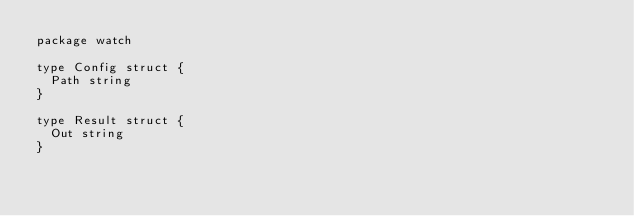<code> <loc_0><loc_0><loc_500><loc_500><_Go_>package watch

type Config struct {
	Path string
}

type Result struct {
	Out string
}
</code> 